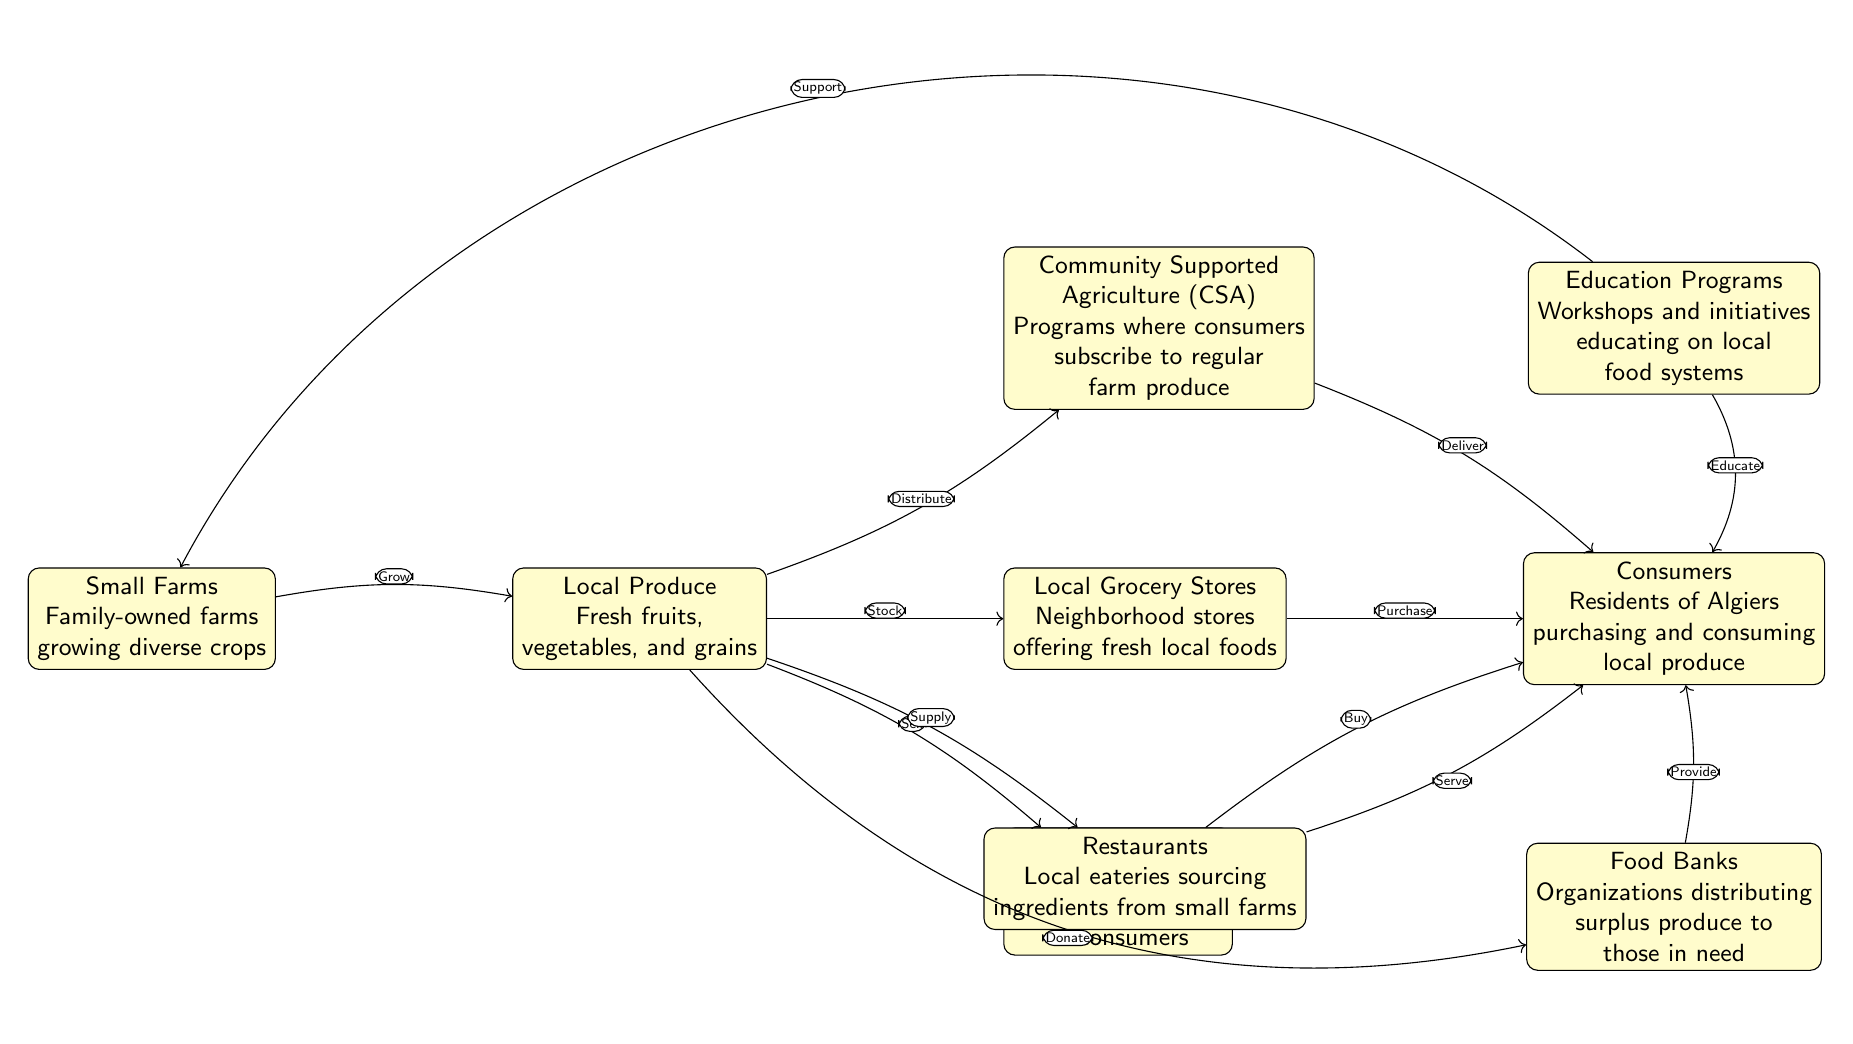What is the main source of local produce in Algiers? The diagram shows that local produce is primarily sourced from small farms, which are family-owned and grow diverse crops.
Answer: Small Farms How many types of market outlets are shown in the diagram? There are three types of market outlets depicted in the diagram: Farmers' Markets, Local Grocery Stores, and Community Supported Agriculture (CSA).
Answer: 3 What do consumers purchase from grocery stores? Consumers purchase fresh local foods that are stocked in local grocery stores as shown in the diagram.
Answer: Fresh local foods Which entity provides surplus produce to those in need? According to the diagram, food banks are responsible for distributing surplus produce to people in need within the community.
Answer: Food Banks How do restaurants acquire their ingredients according to the diagram? The diagram illustrates that restaurants source their ingredients directly from small farms, highlighting the importance of local farming for local eateries.
Answer: Small farms What is the role of education programs in relation to consumers? The education programs are designed to educate consumers about local food systems, thereby enhancing their understanding and engagement with local produce.
Answer: Educate What action do farmers' markets facilitate between small farms and consumers? Farmers' markets enable the buying and selling of local produce directly to consumers from small farms, as indicated in the diagram.
Answer: Buy How does Community Supported Agriculture (CSA) connect to consumers? CSA programs connect consumers by allowing them to subscribe and receive regular deliveries of seasonal produce directly from small farms.
Answer: Deliver What is one way surplus produce is utilized in the community? The diagram shows that surplus produce is donated to food banks, which then provide it to those in need within the community.
Answer: Donate 